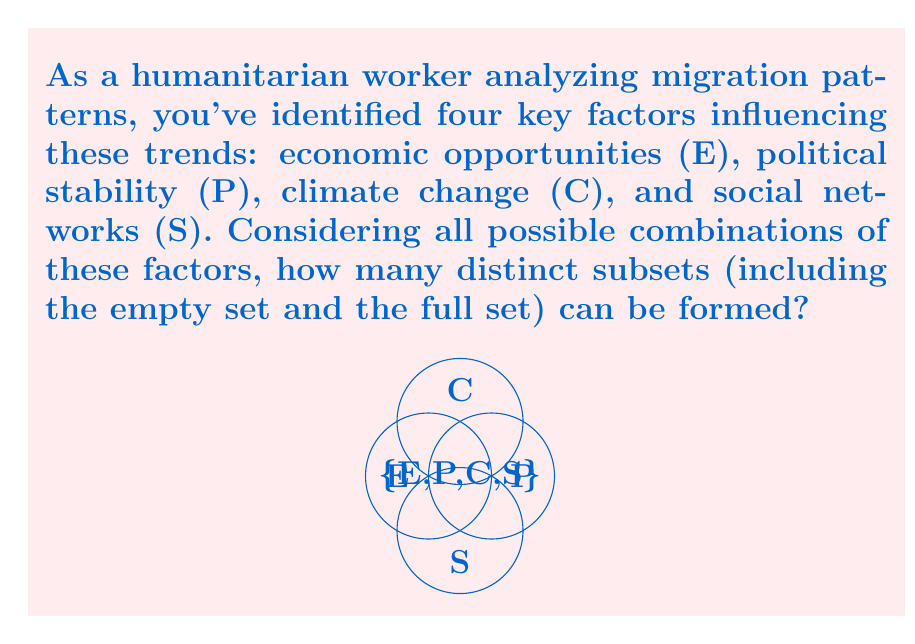Show me your answer to this math problem. To solve this problem, we need to understand the concept of power sets in set theory.

1) First, let's identify our universal set:
   $U = \{E, P, C, S\}$

2) The power set of a set is the set of all possible subsets, including the empty set and the set itself.

3) For a set with $n$ elements, the number of subsets in its power set is given by $2^n$.

4) In our case, we have 4 elements (E, P, C, S), so $n = 4$.

5) Therefore, the number of subsets in the power set is:
   $2^4 = 2 \times 2 \times 2 \times 2 = 16$

6) To verify, we can list all possible subsets:
   - Empty set: $\{\}$
   - Single element sets: $\{E\}, \{P\}, \{C\}, \{S\}$
   - Two element sets: $\{E,P\}, \{E,C\}, \{E,S\}, \{P,C\}, \{P,S\}, \{C,S\}$
   - Three element sets: $\{E,P,C\}, \{E,P,S\}, \{E,C,S\}, \{P,C,S\}$
   - Full set: $\{E,P,C,S\}$

Indeed, we have 16 distinct subsets in total.
Answer: $2^4 = 16$ subsets 